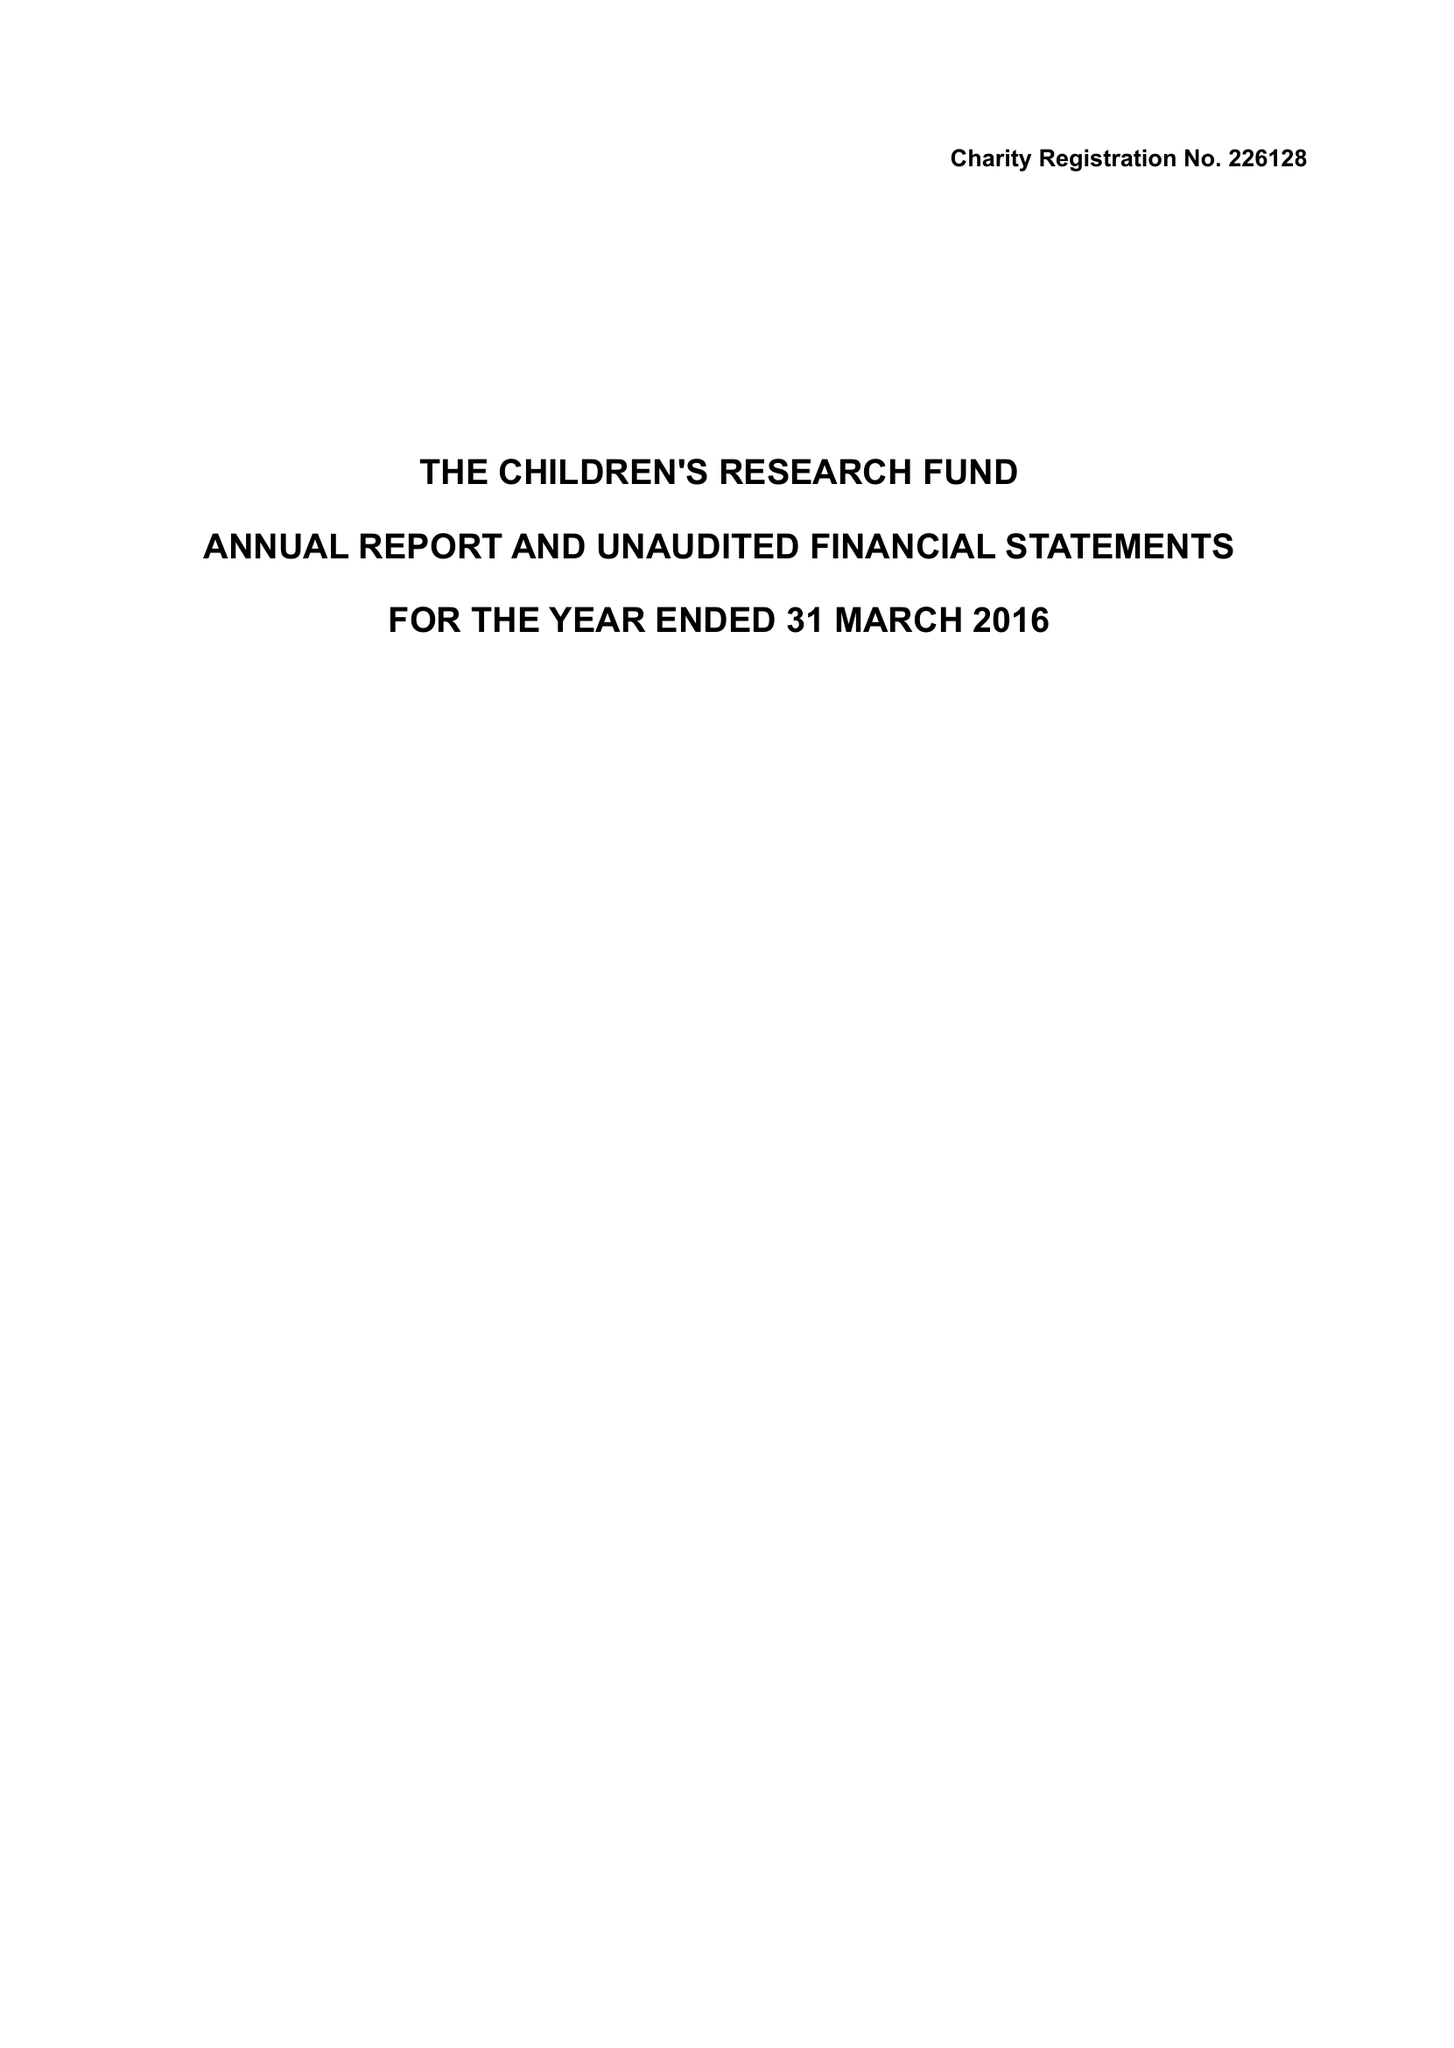What is the value for the address__post_town?
Answer the question using a single word or phrase. RUTHIN 